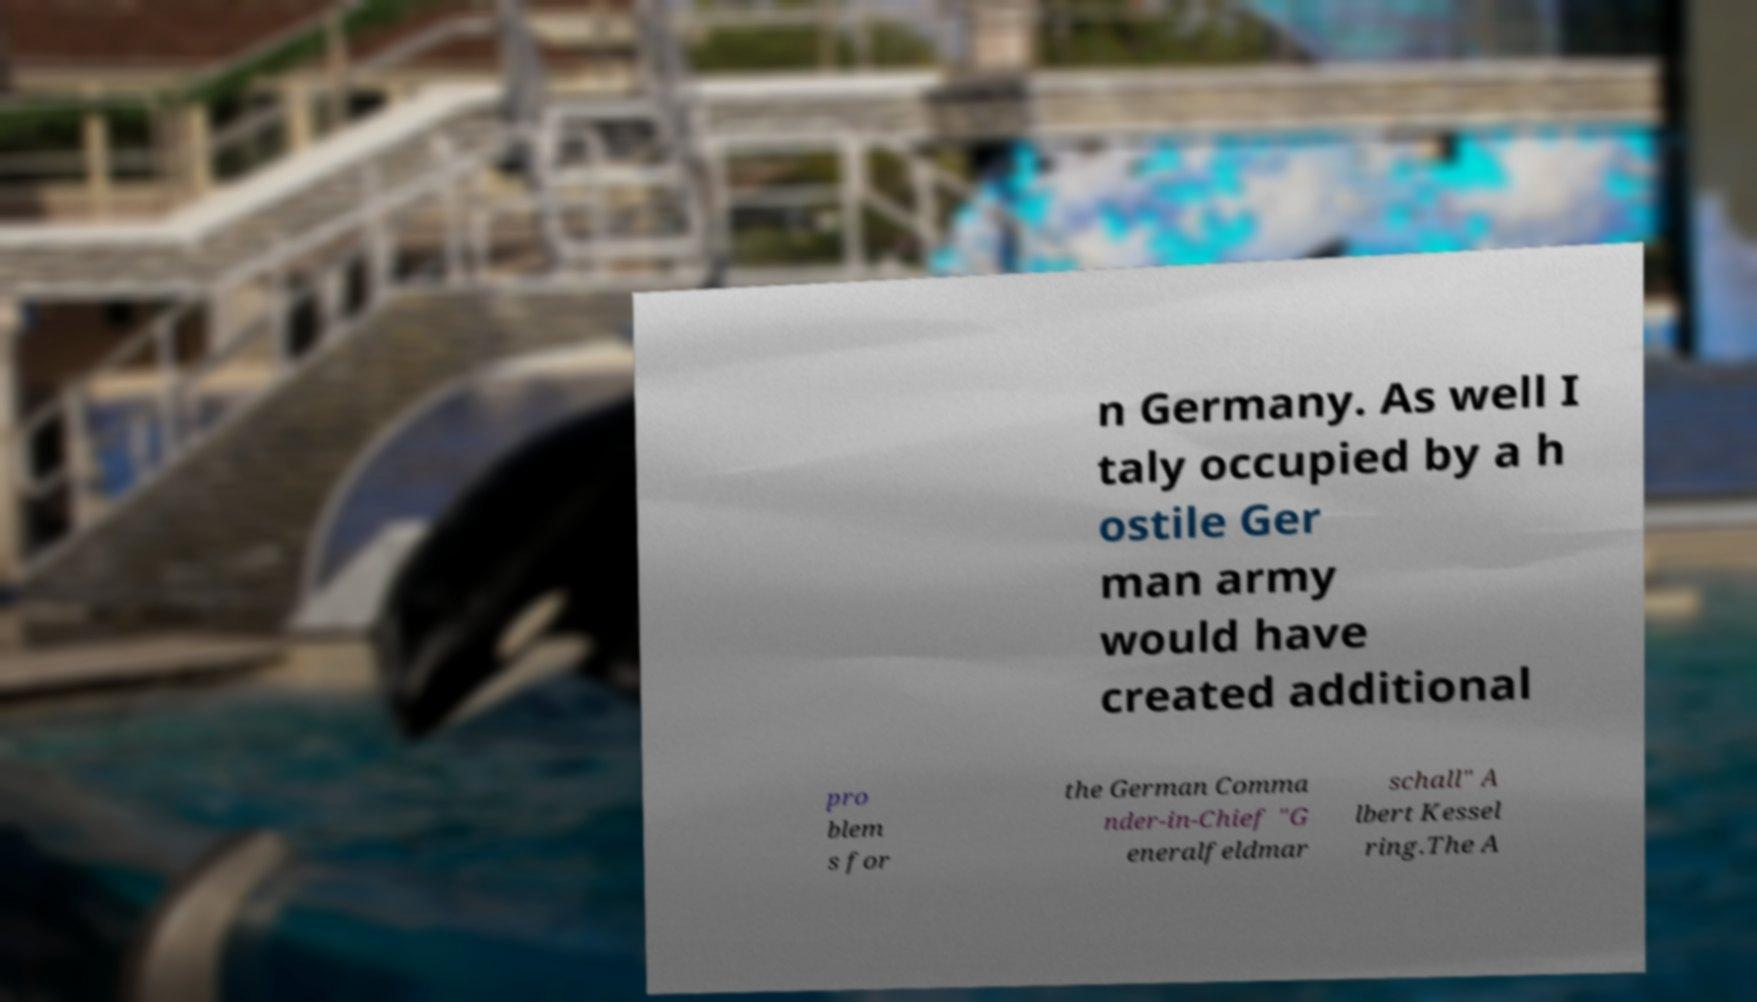I need the written content from this picture converted into text. Can you do that? n Germany. As well I taly occupied by a h ostile Ger man army would have created additional pro blem s for the German Comma nder-in-Chief "G eneralfeldmar schall" A lbert Kessel ring.The A 